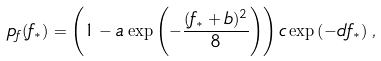Convert formula to latex. <formula><loc_0><loc_0><loc_500><loc_500>p _ { f } ( f _ { * } ) = \left ( 1 - a \exp \left ( - \frac { ( f _ { * } + b ) ^ { 2 } } { 8 } \right ) \right ) c \exp \left ( - d f _ { * } \right ) \, ,</formula> 